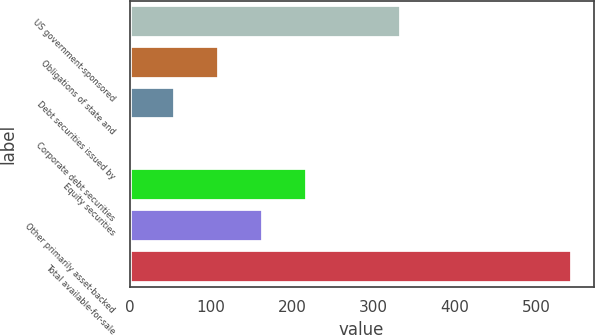Convert chart. <chart><loc_0><loc_0><loc_500><loc_500><bar_chart><fcel>US government-sponsored<fcel>Obligations of state and<fcel>Debt securities issued by<fcel>Corporate debt securities<fcel>Equity securities<fcel>Other primarily asset-backed<fcel>Total available-for-sale<nl><fcel>334<fcel>109.6<fcel>55.3<fcel>1<fcel>218.2<fcel>163.9<fcel>544<nl></chart> 